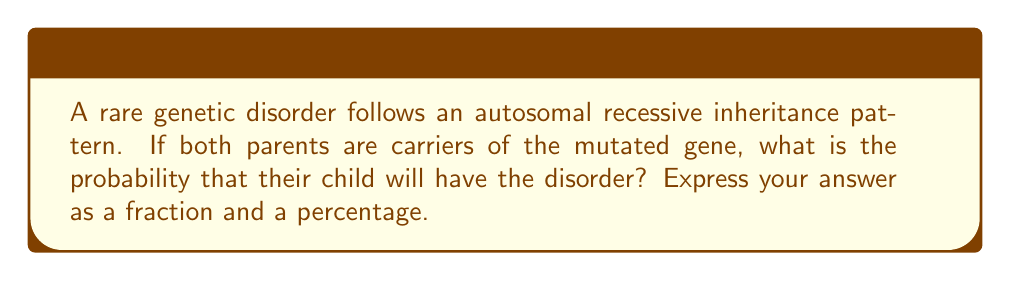Can you solve this math problem? To solve this problem, we need to understand the principles of autosomal recessive inheritance:

1. Each parent has two copies of the gene, one of which is mutated (they are carriers).
2. Each parent will pass on one copy of the gene to their child.
3. The child needs to inherit the mutated gene from both parents to have the disorder.

Let's denote the normal allele as "N" and the mutated allele as "n".

Each parent's genotype: Nn

Possible gametes from each parent:
- N (probability 1/2)
- n (probability 1/2)

We can use a Punnett square to visualize the possible outcomes:

$$
\begin{array}{c|c|c}
 & N (1/2) & n (1/2) \\
\hline
N (1/2) & NN (1/4) & Nn (1/4) \\
\hline
n (1/2) & Nn (1/4) & nn (1/4) \\
\end{array}
$$

The probability of the child having the disorder is the probability of inheriting two mutated alleles (nn), which is 1/4 or 25%.

To express this as a fraction and percentage:
- Fraction: $\frac{1}{4}$
- Percentage: $\frac{1}{4} \times 100\% = 25\%$
Answer: $\frac{1}{4}$ or 25% 